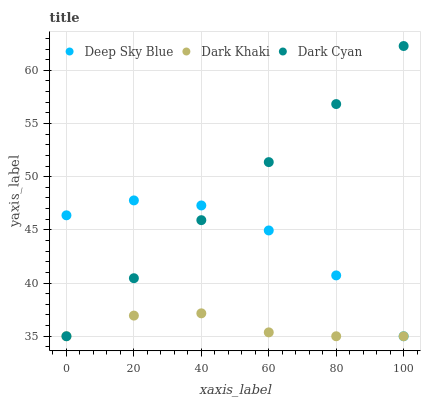Does Dark Khaki have the minimum area under the curve?
Answer yes or no. Yes. Does Dark Cyan have the maximum area under the curve?
Answer yes or no. Yes. Does Deep Sky Blue have the minimum area under the curve?
Answer yes or no. No. Does Deep Sky Blue have the maximum area under the curve?
Answer yes or no. No. Is Dark Cyan the smoothest?
Answer yes or no. Yes. Is Deep Sky Blue the roughest?
Answer yes or no. Yes. Is Deep Sky Blue the smoothest?
Answer yes or no. No. Is Dark Cyan the roughest?
Answer yes or no. No. Does Dark Khaki have the lowest value?
Answer yes or no. Yes. Does Dark Cyan have the highest value?
Answer yes or no. Yes. Does Deep Sky Blue have the highest value?
Answer yes or no. No. Does Deep Sky Blue intersect Dark Khaki?
Answer yes or no. Yes. Is Deep Sky Blue less than Dark Khaki?
Answer yes or no. No. Is Deep Sky Blue greater than Dark Khaki?
Answer yes or no. No. 